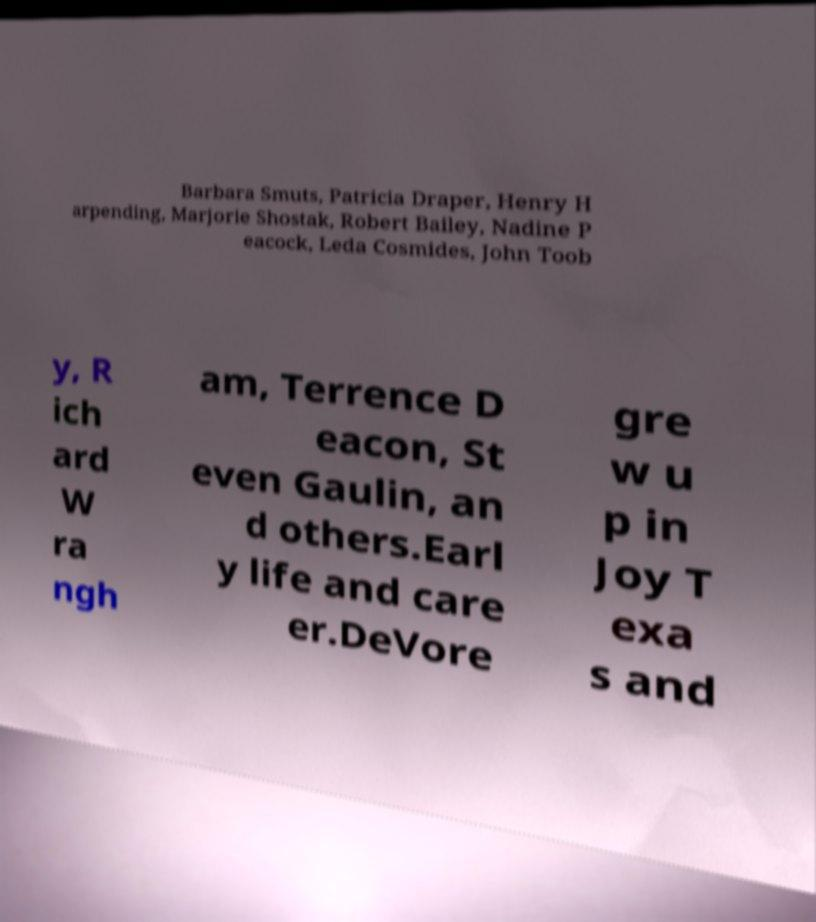Can you accurately transcribe the text from the provided image for me? Barbara Smuts, Patricia Draper, Henry H arpending, Marjorie Shostak, Robert Bailey, Nadine P eacock, Leda Cosmides, John Toob y, R ich ard W ra ngh am, Terrence D eacon, St even Gaulin, an d others.Earl y life and care er.DeVore gre w u p in Joy T exa s and 